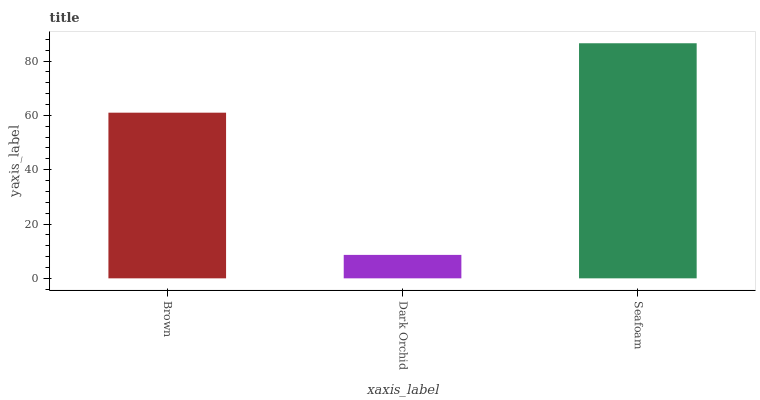Is Dark Orchid the minimum?
Answer yes or no. Yes. Is Seafoam the maximum?
Answer yes or no. Yes. Is Seafoam the minimum?
Answer yes or no. No. Is Dark Orchid the maximum?
Answer yes or no. No. Is Seafoam greater than Dark Orchid?
Answer yes or no. Yes. Is Dark Orchid less than Seafoam?
Answer yes or no. Yes. Is Dark Orchid greater than Seafoam?
Answer yes or no. No. Is Seafoam less than Dark Orchid?
Answer yes or no. No. Is Brown the high median?
Answer yes or no. Yes. Is Brown the low median?
Answer yes or no. Yes. Is Dark Orchid the high median?
Answer yes or no. No. Is Seafoam the low median?
Answer yes or no. No. 